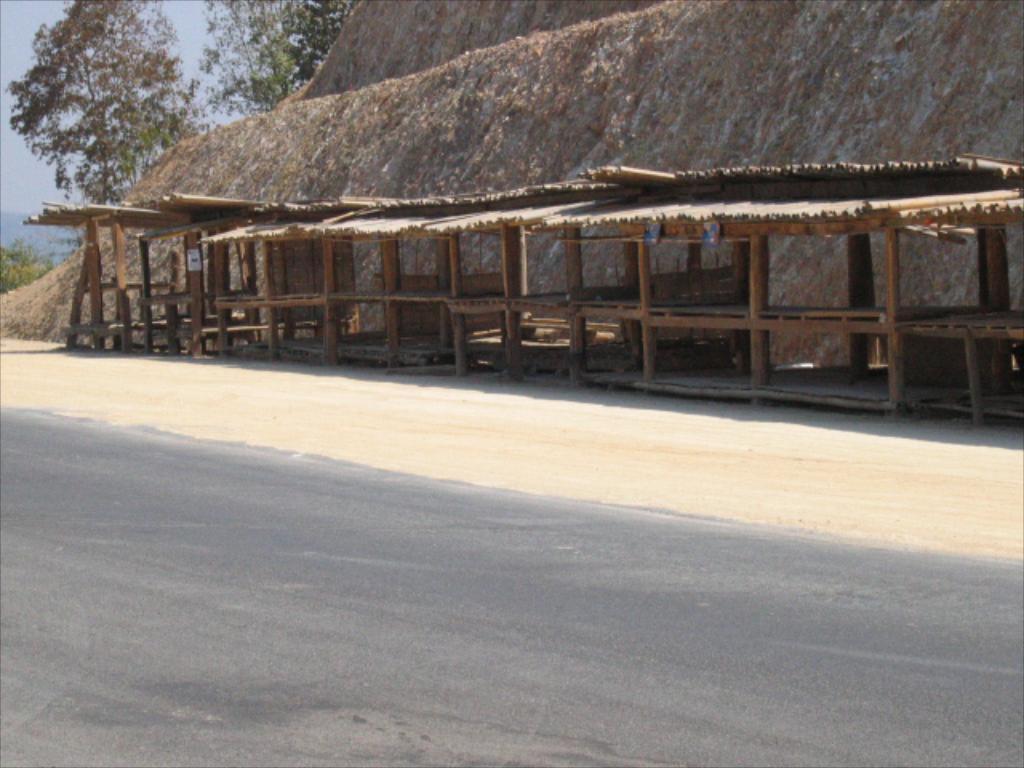Describe this image in one or two sentences. In this image I see the shed over here and I see the path. In the background I see the trees, plants and the sky. 